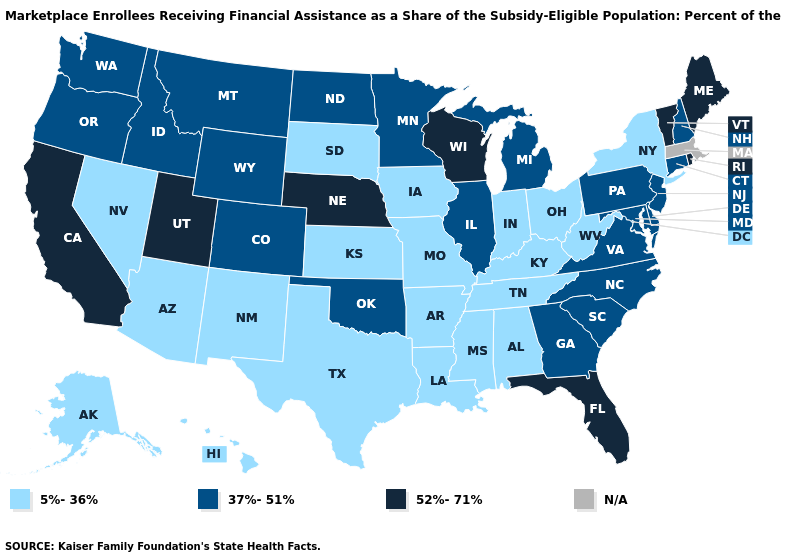Name the states that have a value in the range 37%-51%?
Answer briefly. Colorado, Connecticut, Delaware, Georgia, Idaho, Illinois, Maryland, Michigan, Minnesota, Montana, New Hampshire, New Jersey, North Carolina, North Dakota, Oklahoma, Oregon, Pennsylvania, South Carolina, Virginia, Washington, Wyoming. Name the states that have a value in the range 37%-51%?
Be succinct. Colorado, Connecticut, Delaware, Georgia, Idaho, Illinois, Maryland, Michigan, Minnesota, Montana, New Hampshire, New Jersey, North Carolina, North Dakota, Oklahoma, Oregon, Pennsylvania, South Carolina, Virginia, Washington, Wyoming. What is the value of Alaska?
Short answer required. 5%-36%. Name the states that have a value in the range 37%-51%?
Answer briefly. Colorado, Connecticut, Delaware, Georgia, Idaho, Illinois, Maryland, Michigan, Minnesota, Montana, New Hampshire, New Jersey, North Carolina, North Dakota, Oklahoma, Oregon, Pennsylvania, South Carolina, Virginia, Washington, Wyoming. What is the lowest value in the USA?
Quick response, please. 5%-36%. What is the value of Montana?
Short answer required. 37%-51%. Does Idaho have the lowest value in the West?
Short answer required. No. What is the value of New Jersey?
Quick response, please. 37%-51%. Which states have the highest value in the USA?
Answer briefly. California, Florida, Maine, Nebraska, Rhode Island, Utah, Vermont, Wisconsin. What is the highest value in the USA?
Keep it brief. 52%-71%. What is the value of North Carolina?
Give a very brief answer. 37%-51%. Name the states that have a value in the range 37%-51%?
Keep it brief. Colorado, Connecticut, Delaware, Georgia, Idaho, Illinois, Maryland, Michigan, Minnesota, Montana, New Hampshire, New Jersey, North Carolina, North Dakota, Oklahoma, Oregon, Pennsylvania, South Carolina, Virginia, Washington, Wyoming. Name the states that have a value in the range N/A?
Give a very brief answer. Massachusetts. 